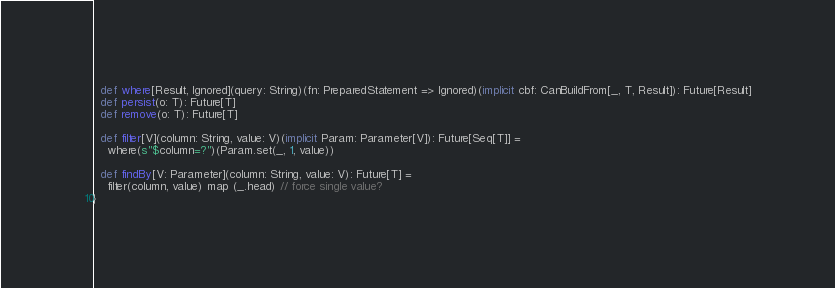Convert code to text. <code><loc_0><loc_0><loc_500><loc_500><_Scala_>  def where[Result, Ignored](query: String)(fn: PreparedStatement => Ignored)(implicit cbf: CanBuildFrom[_, T, Result]): Future[Result]
  def persist(o: T): Future[T]
  def remove(o: T): Future[T]

  def filter[V](column: String, value: V)(implicit Param: Parameter[V]): Future[Seq[T]] =
    where(s"$column=?")(Param.set(_, 1, value))
  
  def findBy[V: Parameter](column: String, value: V): Future[T] =
    filter(column, value) map (_.head) // force single value?
}
</code> 